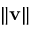Convert formula to latex. <formula><loc_0><loc_0><loc_500><loc_500>\| v \|</formula> 